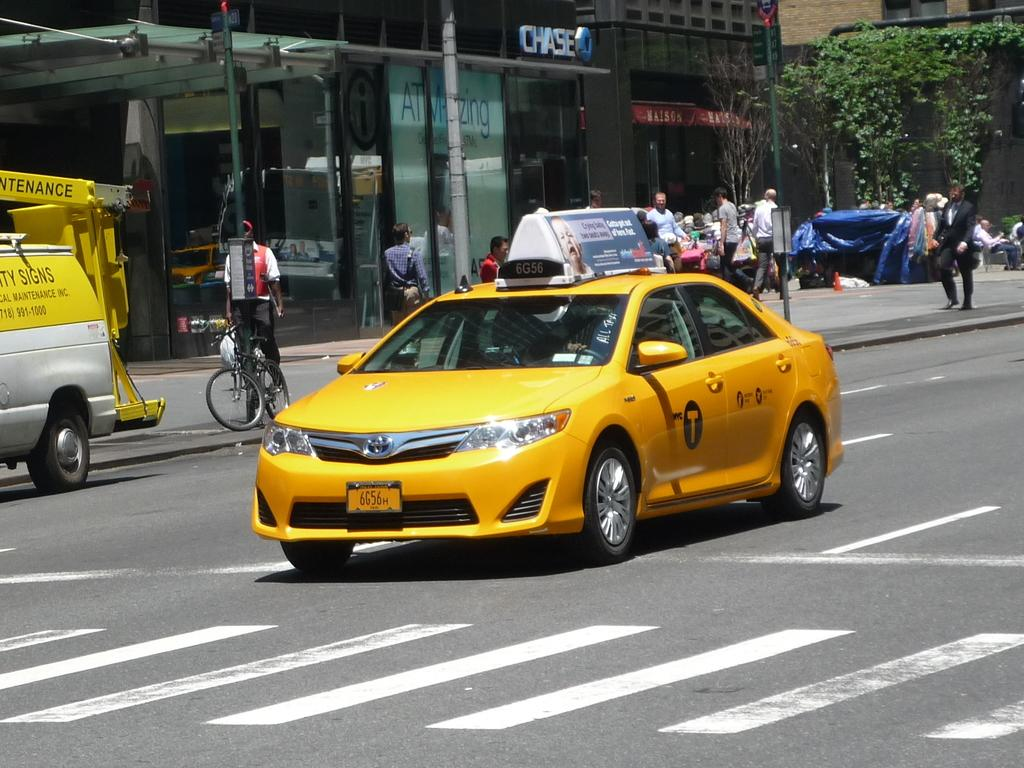<image>
Offer a succinct explanation of the picture presented. a cab that has the letter T on it 